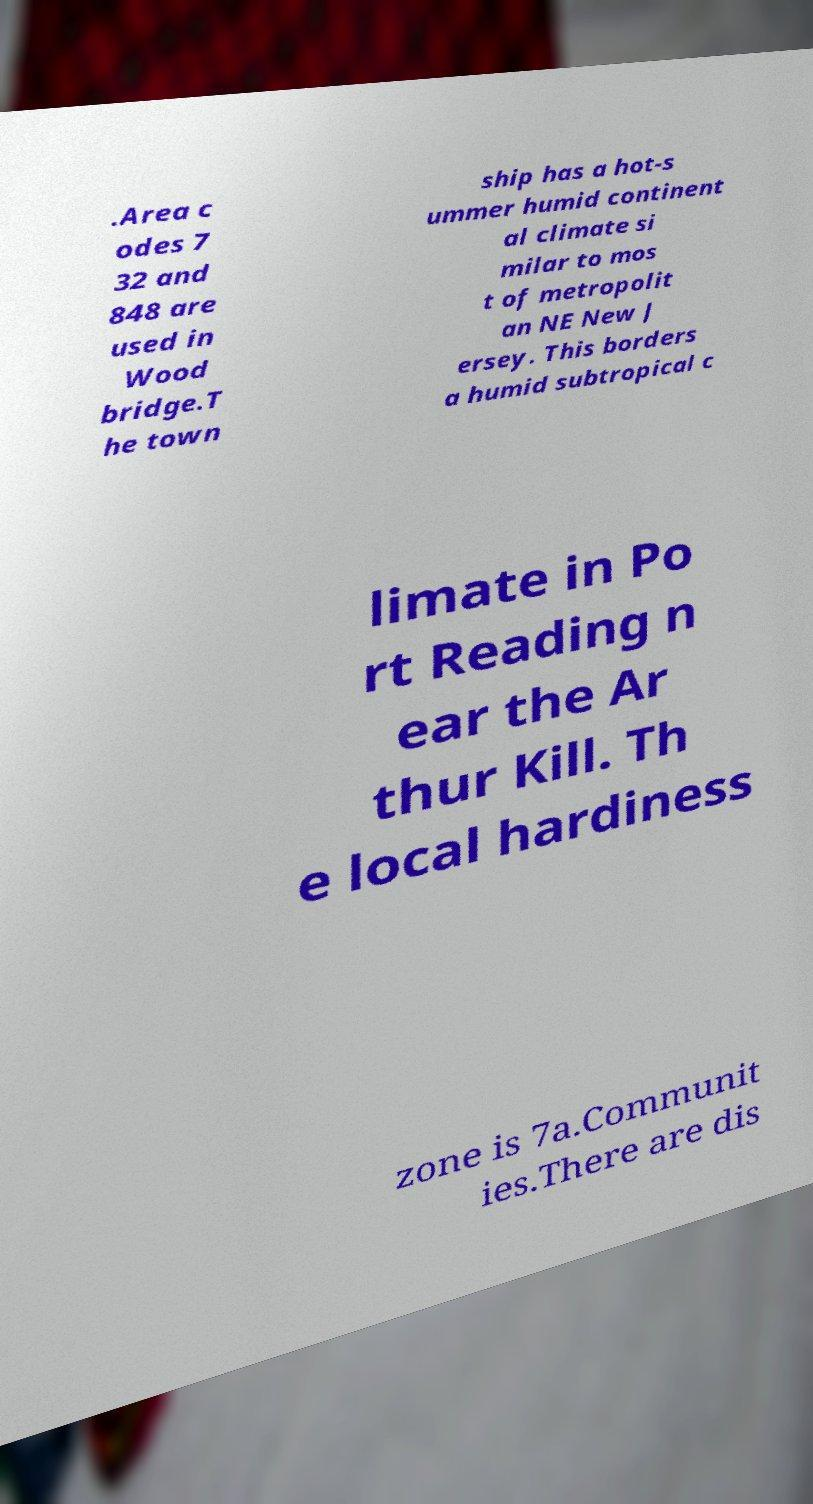Could you assist in decoding the text presented in this image and type it out clearly? .Area c odes 7 32 and 848 are used in Wood bridge.T he town ship has a hot-s ummer humid continent al climate si milar to mos t of metropolit an NE New J ersey. This borders a humid subtropical c limate in Po rt Reading n ear the Ar thur Kill. Th e local hardiness zone is 7a.Communit ies.There are dis 